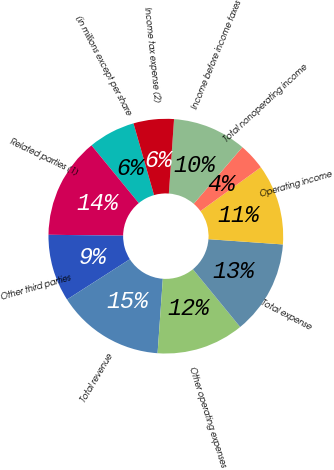Convert chart. <chart><loc_0><loc_0><loc_500><loc_500><pie_chart><fcel>(in millions except per share<fcel>Related parties (1)<fcel>Other third parties<fcel>Total revenue<fcel>Other operating expenses<fcel>Total expense<fcel>Operating income<fcel>Total nonoperating income<fcel>Income before income taxes<fcel>Income tax expense (2)<nl><fcel>6.48%<fcel>13.89%<fcel>9.26%<fcel>14.81%<fcel>12.04%<fcel>12.96%<fcel>11.11%<fcel>3.71%<fcel>10.19%<fcel>5.56%<nl></chart> 